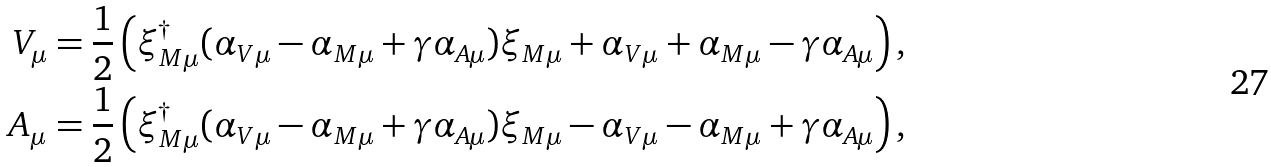<formula> <loc_0><loc_0><loc_500><loc_500>V _ { \mu } & = \frac { 1 } { 2 } \left ( \xi _ { M \mu } ^ { \dagger } ( \alpha _ { V \mu } - \alpha _ { M \mu } + \gamma \alpha _ { A \mu } ) \xi _ { M \mu } + \alpha _ { V \mu } + \alpha _ { M \mu } - \gamma \alpha _ { A \mu } \right ) , \\ A _ { \mu } & = \frac { 1 } { 2 } \left ( \xi _ { M \mu } ^ { \dagger } ( \alpha _ { V \mu } - \alpha _ { M \mu } + \gamma \alpha _ { A \mu } ) \xi _ { M \mu } - \alpha _ { V \mu } - \alpha _ { M \mu } + \gamma \alpha _ { A \mu } \right ) ,</formula> 